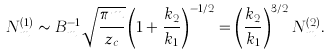Convert formula to latex. <formula><loc_0><loc_0><loc_500><loc_500>N ^ { ( 1 ) } _ { m } \sim B _ { m } ^ { - 1 } \sqrt { \frac { \pi m } { z _ { c } } } \left ( 1 + \frac { k _ { 2 } } { k _ { 1 } } \right ) ^ { - 1 / 2 } = \left ( \frac { k _ { 2 } } { k _ { 1 } } \right ) ^ { 3 / 2 } N ^ { ( 2 ) } _ { m } .</formula> 